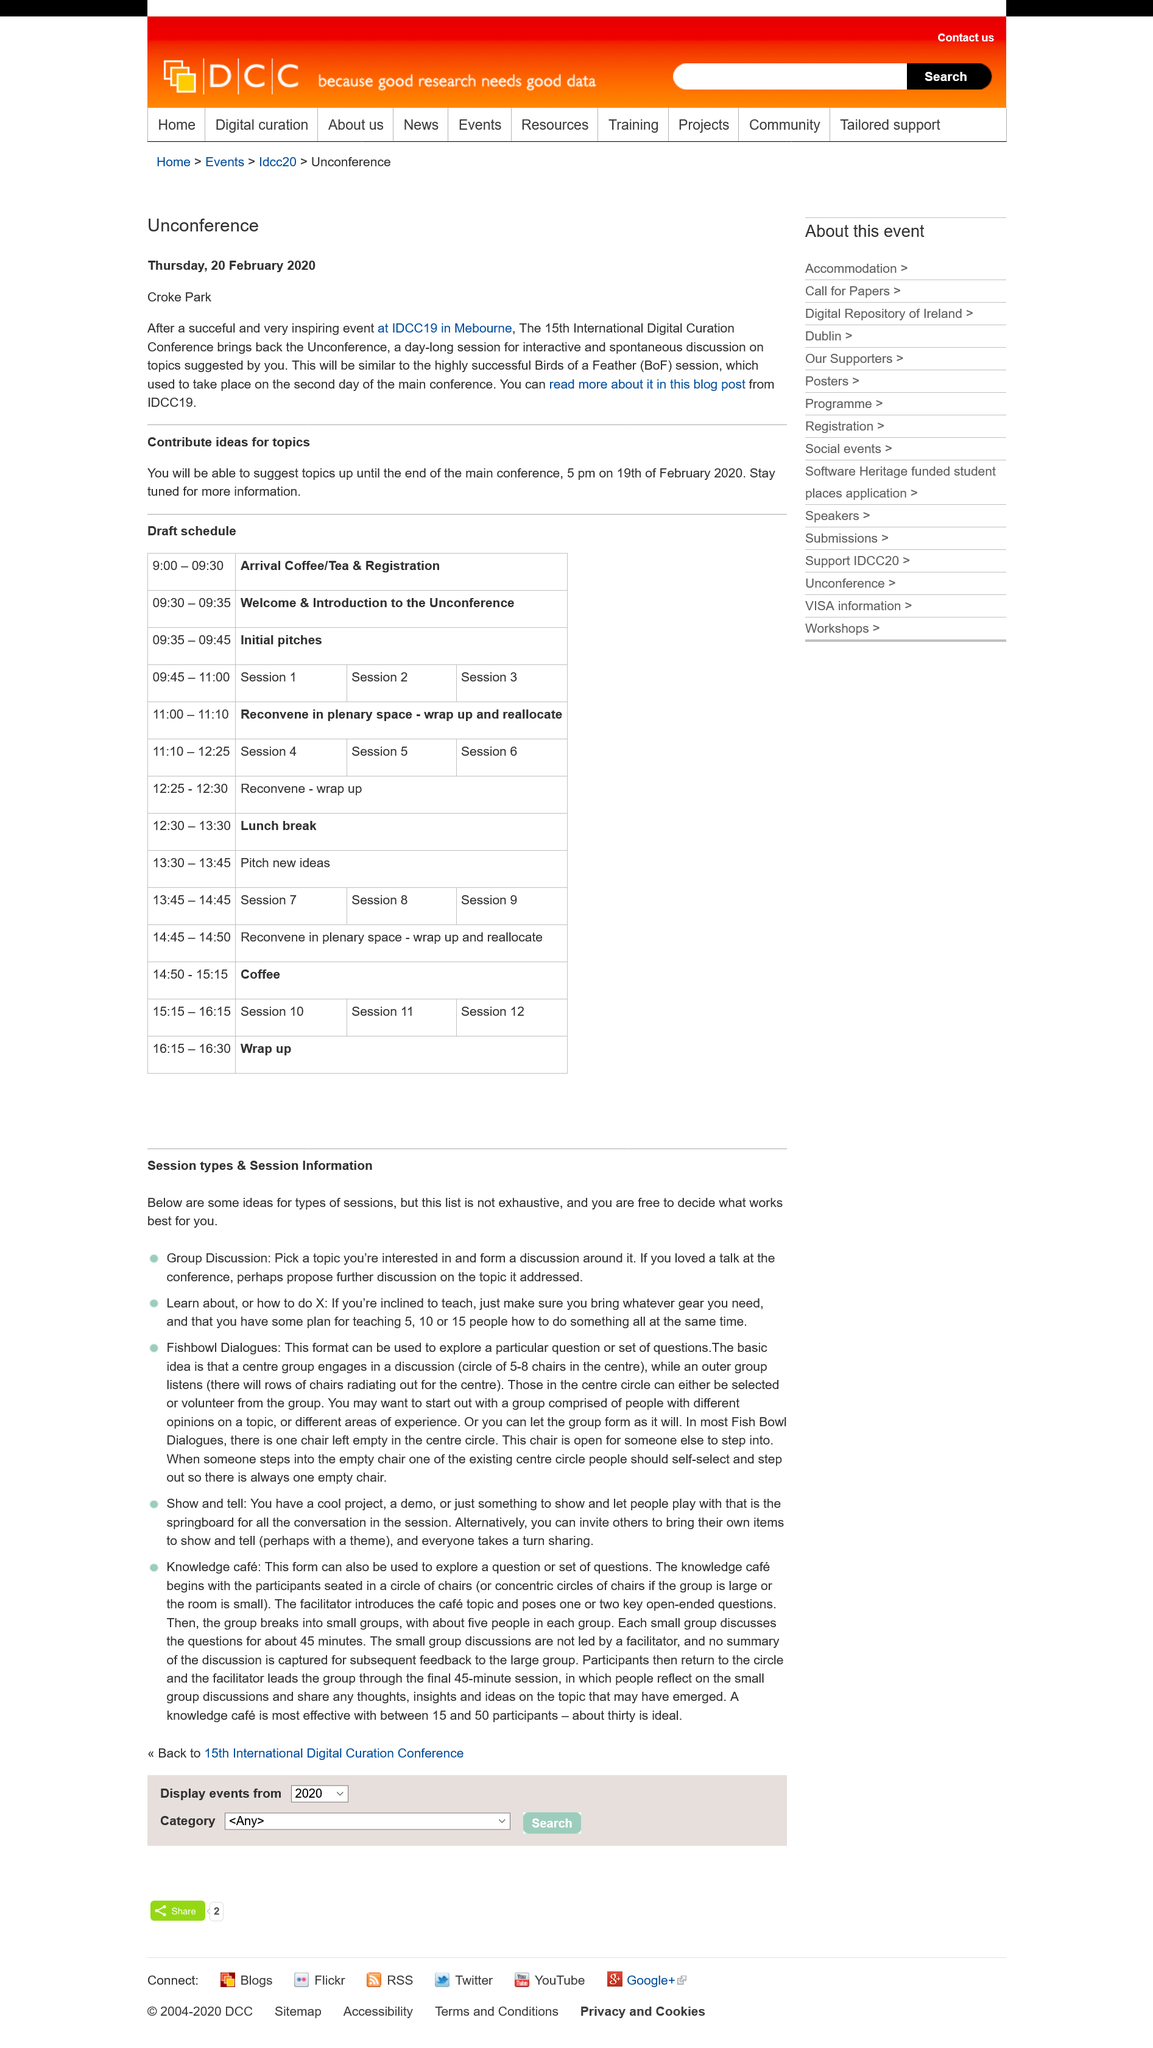List a handful of essential elements in this visual. The process of holding a group discussion session involves selecting a topic of interest and facilitating a discussion around it. The title of this page is "Session types and Session Information". The list of sessions is not exhaustive, and there may be additional sessions that are not included in this list. 